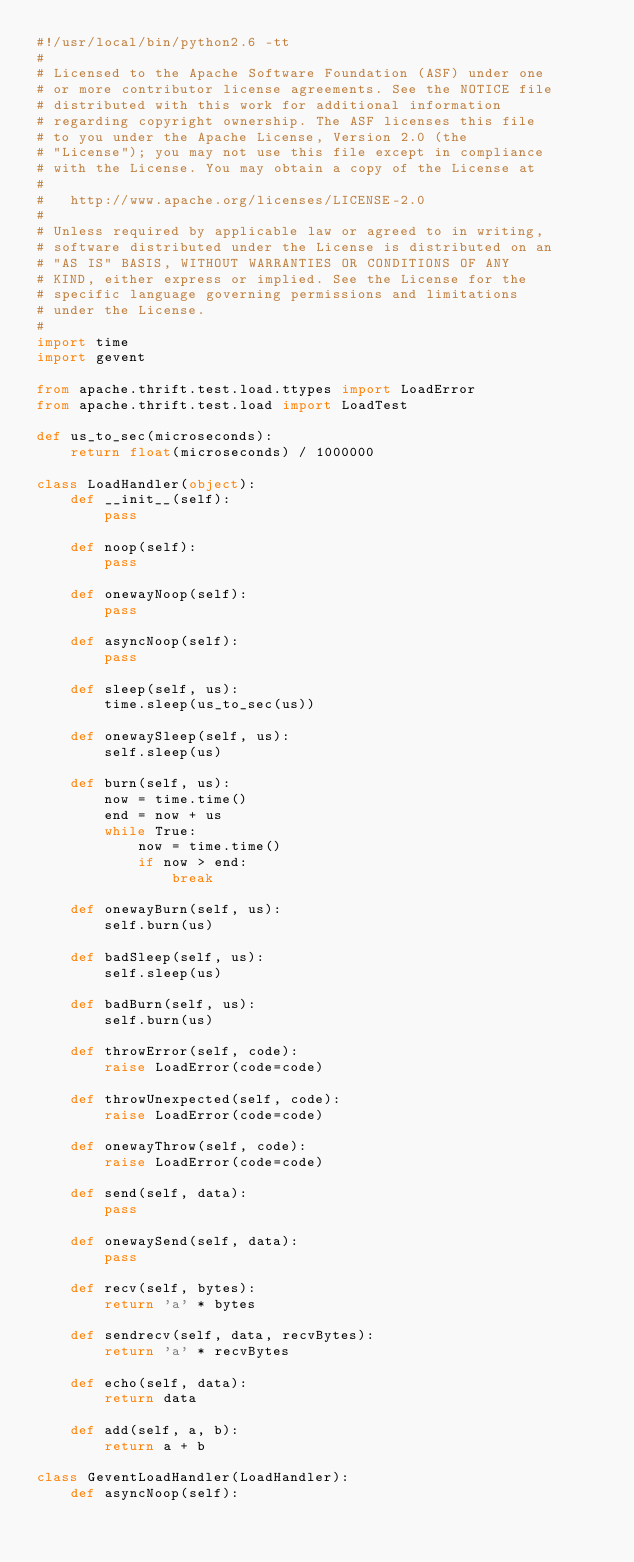Convert code to text. <code><loc_0><loc_0><loc_500><loc_500><_Python_>#!/usr/local/bin/python2.6 -tt
#
# Licensed to the Apache Software Foundation (ASF) under one
# or more contributor license agreements. See the NOTICE file
# distributed with this work for additional information
# regarding copyright ownership. The ASF licenses this file
# to you under the Apache License, Version 2.0 (the
# "License"); you may not use this file except in compliance
# with the License. You may obtain a copy of the License at
#
#   http://www.apache.org/licenses/LICENSE-2.0
#
# Unless required by applicable law or agreed to in writing,
# software distributed under the License is distributed on an
# "AS IS" BASIS, WITHOUT WARRANTIES OR CONDITIONS OF ANY
# KIND, either express or implied. See the License for the
# specific language governing permissions and limitations
# under the License.
#
import time
import gevent

from apache.thrift.test.load.ttypes import LoadError
from apache.thrift.test.load import LoadTest

def us_to_sec(microseconds):
    return float(microseconds) / 1000000

class LoadHandler(object):
    def __init__(self):
        pass

    def noop(self):
        pass

    def onewayNoop(self):
        pass

    def asyncNoop(self):
        pass

    def sleep(self, us):
        time.sleep(us_to_sec(us))

    def onewaySleep(self, us):
        self.sleep(us)

    def burn(self, us):
        now = time.time()
        end = now + us
        while True:
            now = time.time()
            if now > end:
                break

    def onewayBurn(self, us):
        self.burn(us)

    def badSleep(self, us):
        self.sleep(us)

    def badBurn(self, us):
        self.burn(us)

    def throwError(self, code):
        raise LoadError(code=code)

    def throwUnexpected(self, code):
        raise LoadError(code=code)

    def onewayThrow(self, code):
        raise LoadError(code=code)

    def send(self, data):
        pass

    def onewaySend(self, data):
        pass

    def recv(self, bytes):
        return 'a' * bytes

    def sendrecv(self, data, recvBytes):
        return 'a' * recvBytes

    def echo(self, data):
        return data

    def add(self, a, b):
        return a + b

class GeventLoadHandler(LoadHandler):
    def asyncNoop(self):</code> 